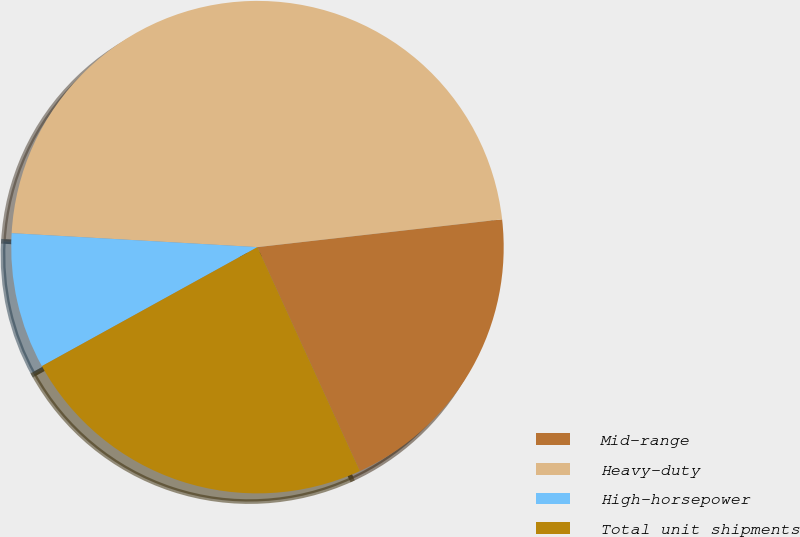<chart> <loc_0><loc_0><loc_500><loc_500><pie_chart><fcel>Mid-range<fcel>Heavy-duty<fcel>High-horsepower<fcel>Total unit shipments<nl><fcel>19.97%<fcel>47.29%<fcel>8.93%<fcel>23.8%<nl></chart> 